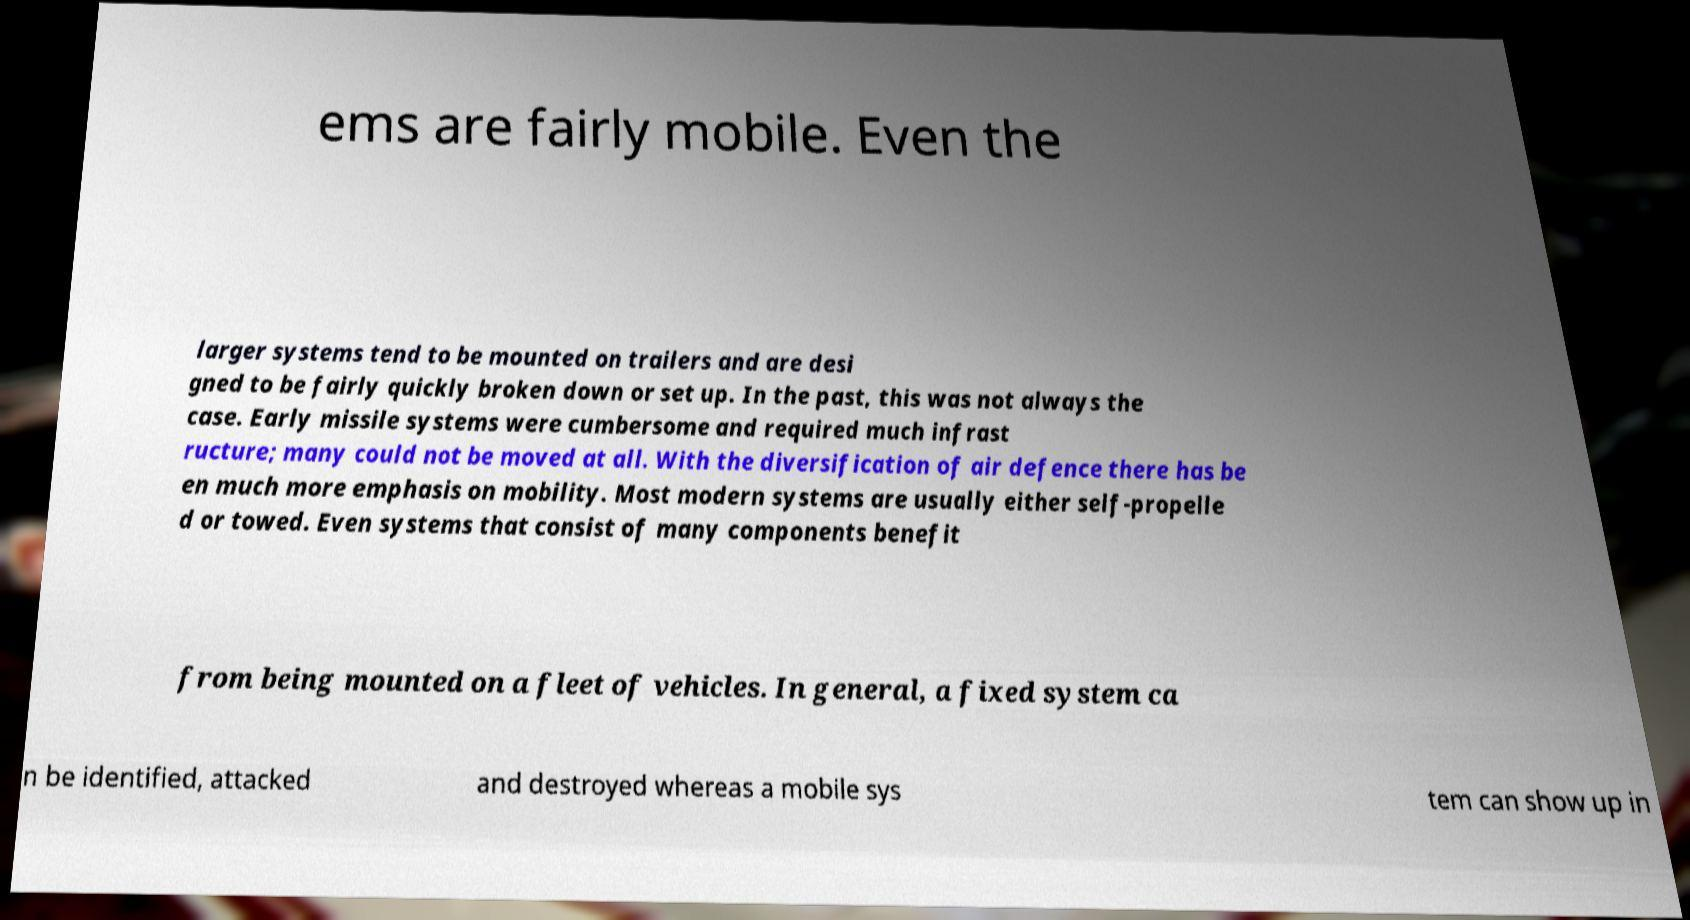For documentation purposes, I need the text within this image transcribed. Could you provide that? ems are fairly mobile. Even the larger systems tend to be mounted on trailers and are desi gned to be fairly quickly broken down or set up. In the past, this was not always the case. Early missile systems were cumbersome and required much infrast ructure; many could not be moved at all. With the diversification of air defence there has be en much more emphasis on mobility. Most modern systems are usually either self-propelle d or towed. Even systems that consist of many components benefit from being mounted on a fleet of vehicles. In general, a fixed system ca n be identified, attacked and destroyed whereas a mobile sys tem can show up in 